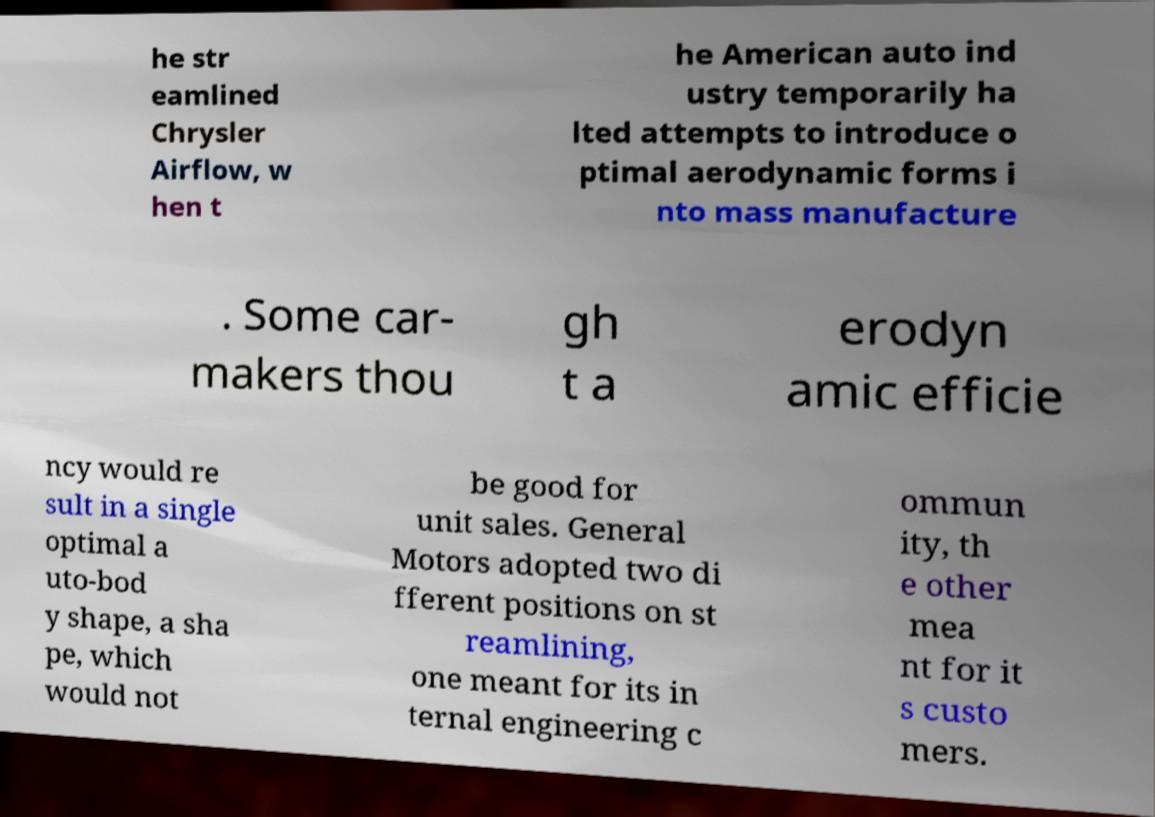Could you assist in decoding the text presented in this image and type it out clearly? he str eamlined Chrysler Airflow, w hen t he American auto ind ustry temporarily ha lted attempts to introduce o ptimal aerodynamic forms i nto mass manufacture . Some car- makers thou gh t a erodyn amic efficie ncy would re sult in a single optimal a uto-bod y shape, a sha pe, which would not be good for unit sales. General Motors adopted two di fferent positions on st reamlining, one meant for its in ternal engineering c ommun ity, th e other mea nt for it s custo mers. 